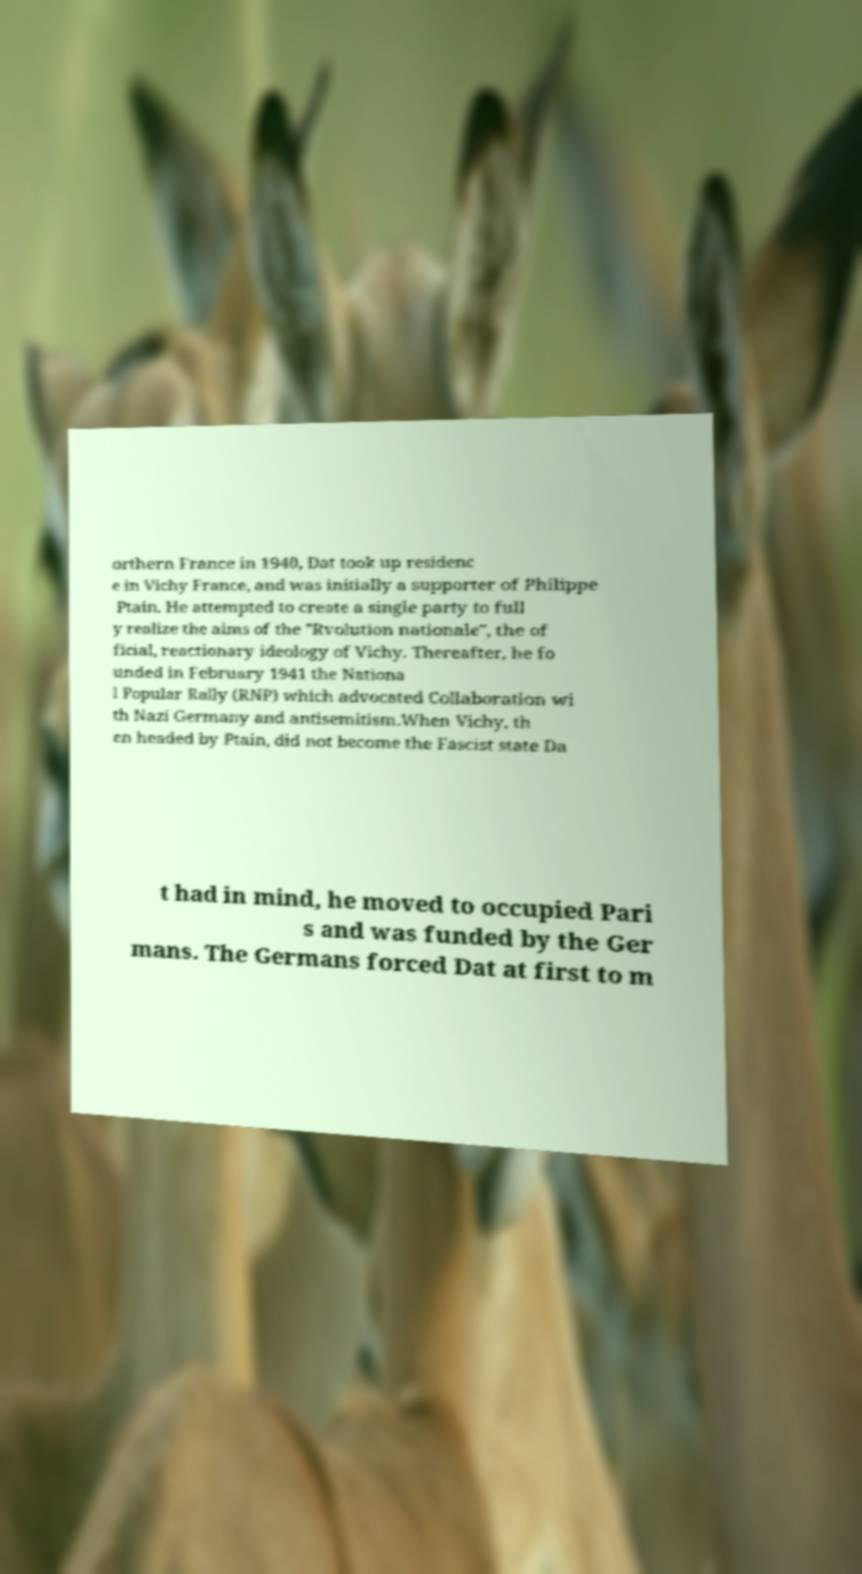Can you accurately transcribe the text from the provided image for me? orthern France in 1940, Dat took up residenc e in Vichy France, and was initially a supporter of Philippe Ptain. He attempted to create a single party to full y realize the aims of the "Rvolution nationale", the of ficial, reactionary ideology of Vichy. Thereafter, he fo unded in February 1941 the Nationa l Popular Rally (RNP) which advocated Collaboration wi th Nazi Germany and antisemitism.When Vichy, th en headed by Ptain, did not become the Fascist state Da t had in mind, he moved to occupied Pari s and was funded by the Ger mans. The Germans forced Dat at first to m 